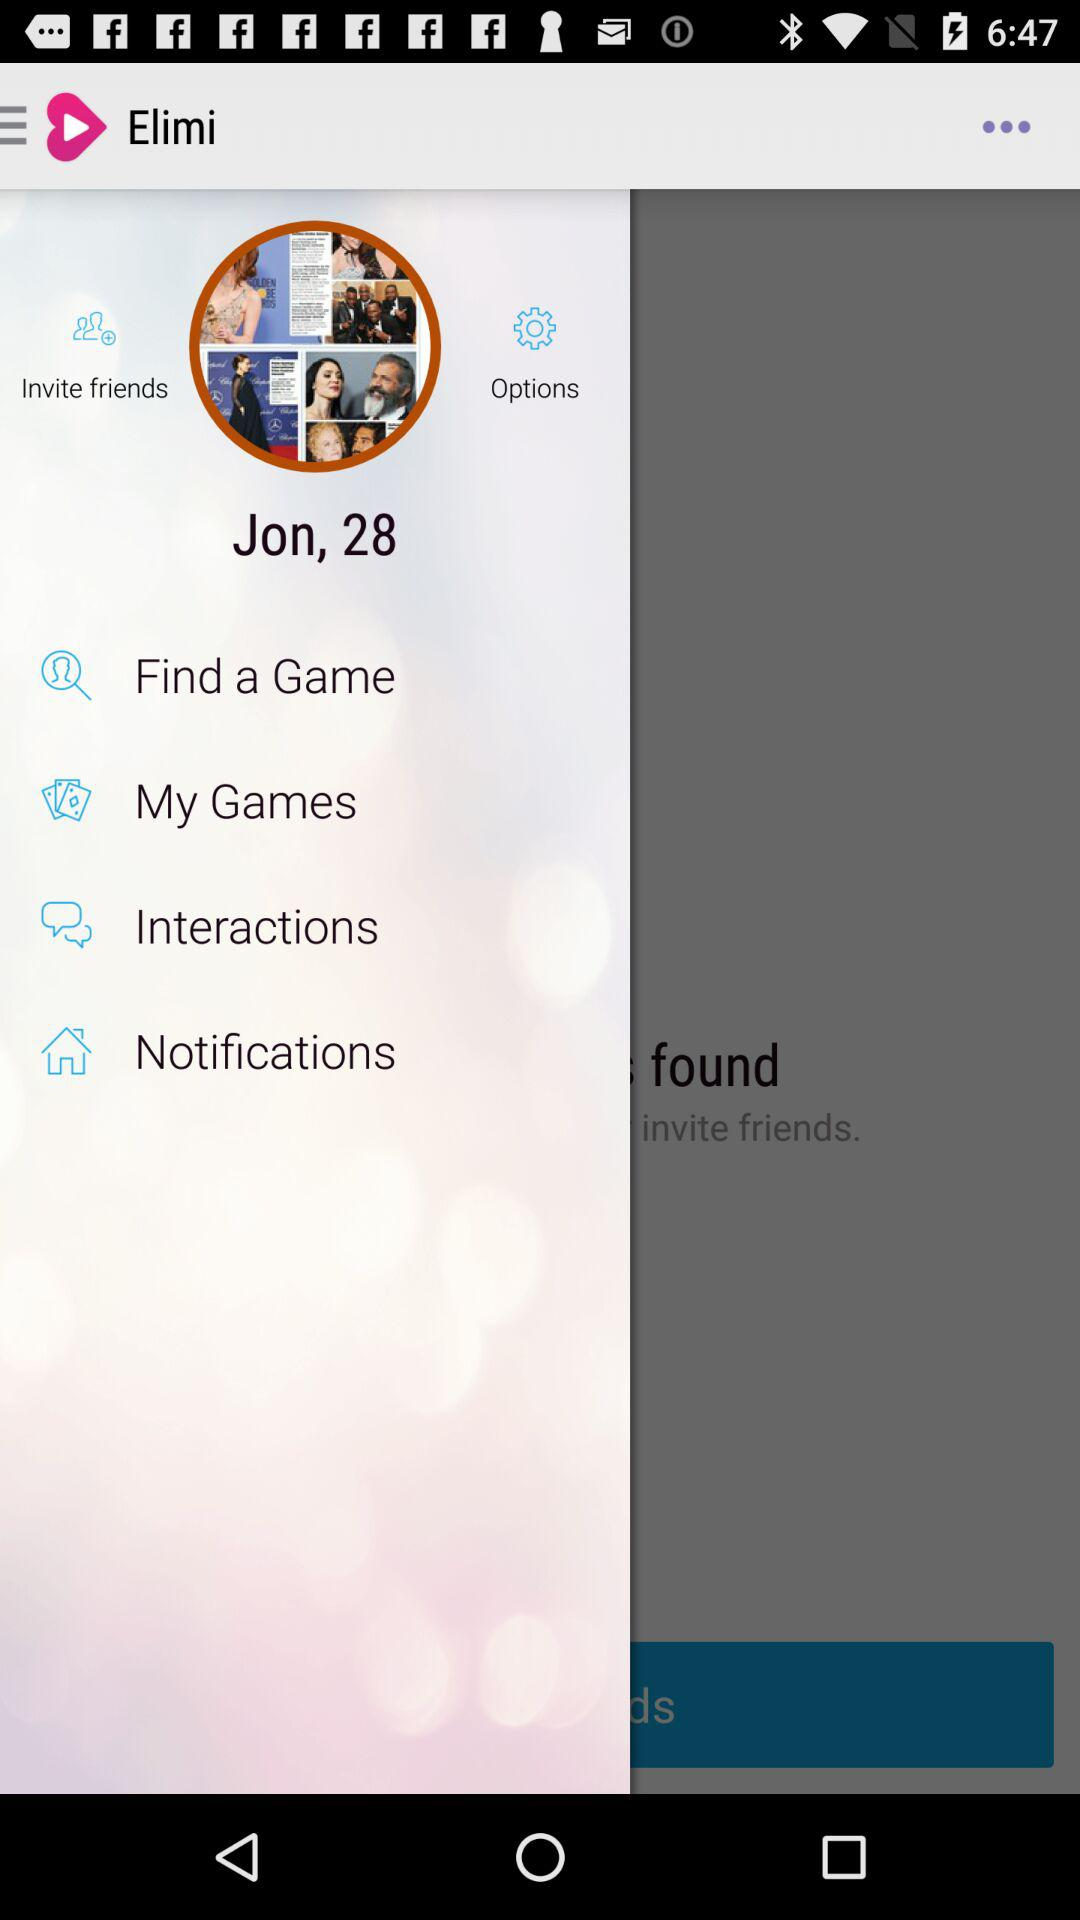What is the age of Jon? Jon is 28 years old. 